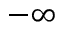Convert formula to latex. <formula><loc_0><loc_0><loc_500><loc_500>- \infty</formula> 